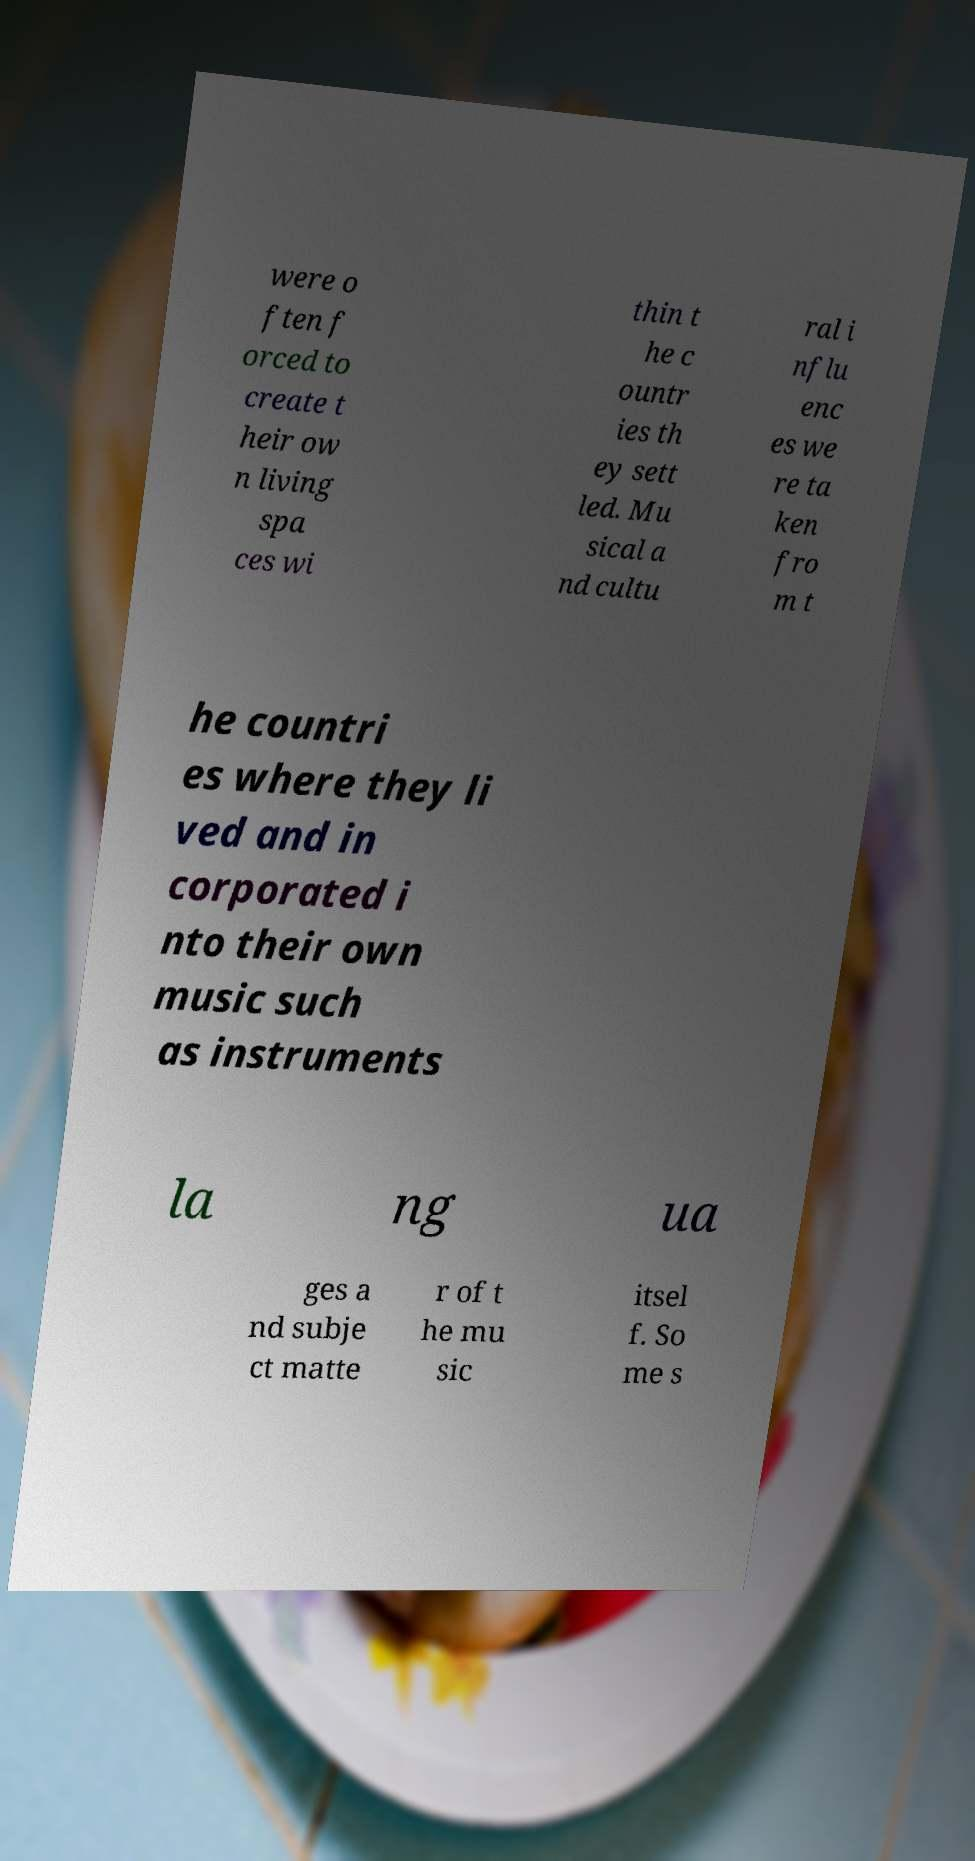For documentation purposes, I need the text within this image transcribed. Could you provide that? were o ften f orced to create t heir ow n living spa ces wi thin t he c ountr ies th ey sett led. Mu sical a nd cultu ral i nflu enc es we re ta ken fro m t he countri es where they li ved and in corporated i nto their own music such as instruments la ng ua ges a nd subje ct matte r of t he mu sic itsel f. So me s 